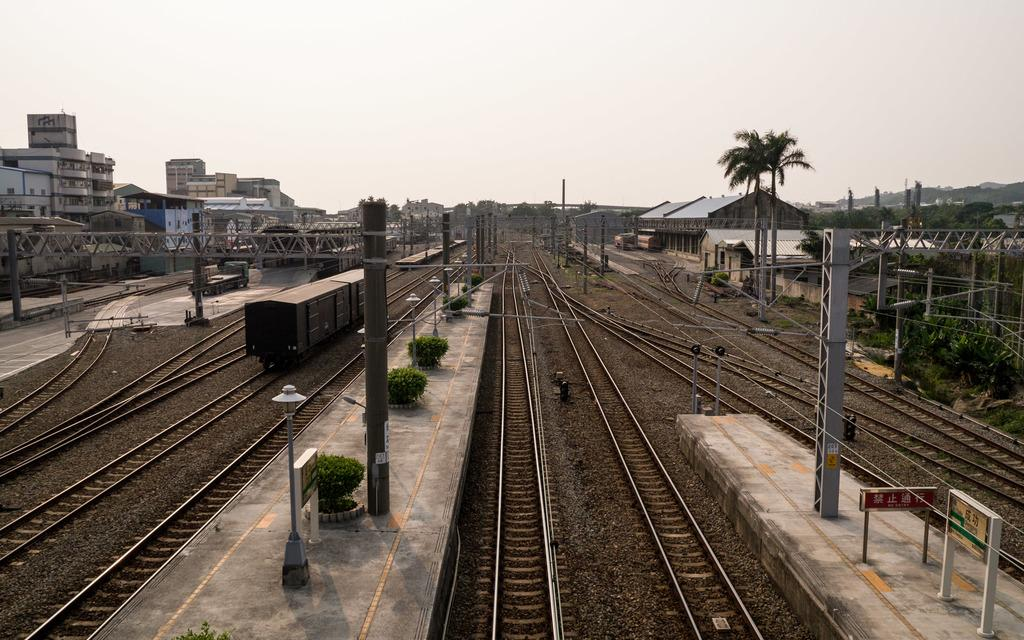What can be seen running through the image? There are tracks in the image, and a train is on the tracks. What is located near the tracks? There is a platform in the image. What type of vegetation is visible in the image? There are trees in the image. What type of structures can be seen in the image? There are buildings in the image. What else can be seen in the image besides the tracks, train, platform, trees, and buildings? There are poles in the image. What type of competition is taking place on the platform in the image? There is no competition present in the image; it features a train on tracks, a platform, trees, buildings, and poles. What is the order of the buildings in the image? The order of the buildings cannot be determined from the image alone, as they are not arranged in a specific sequence. 